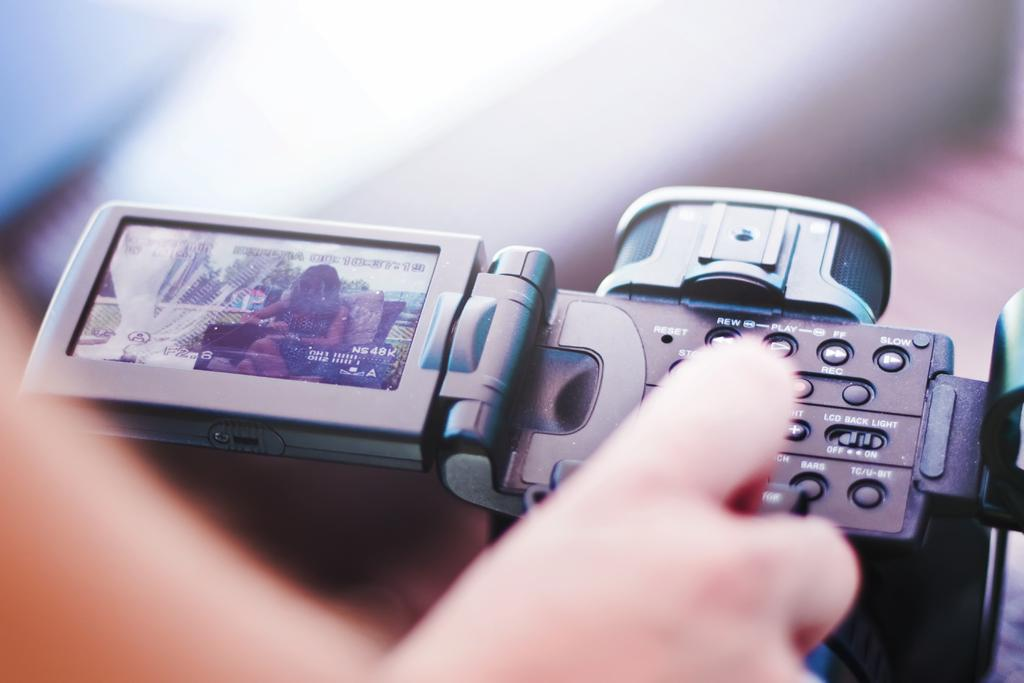What part of a person is visible in the image? There is a person's hand in the image. Where is the hand located in the image? The hand is located at the bottom of the image. What is the main object in the middle of the image? There is a camera in the middle of the image. What type of rock can be seen in the hand of the person in the image? There is no rock visible in the hand of the person in the image. Can you describe the woman standing next to the camera in the image? There is no woman present in the image; only a hand and a camera are visible. 